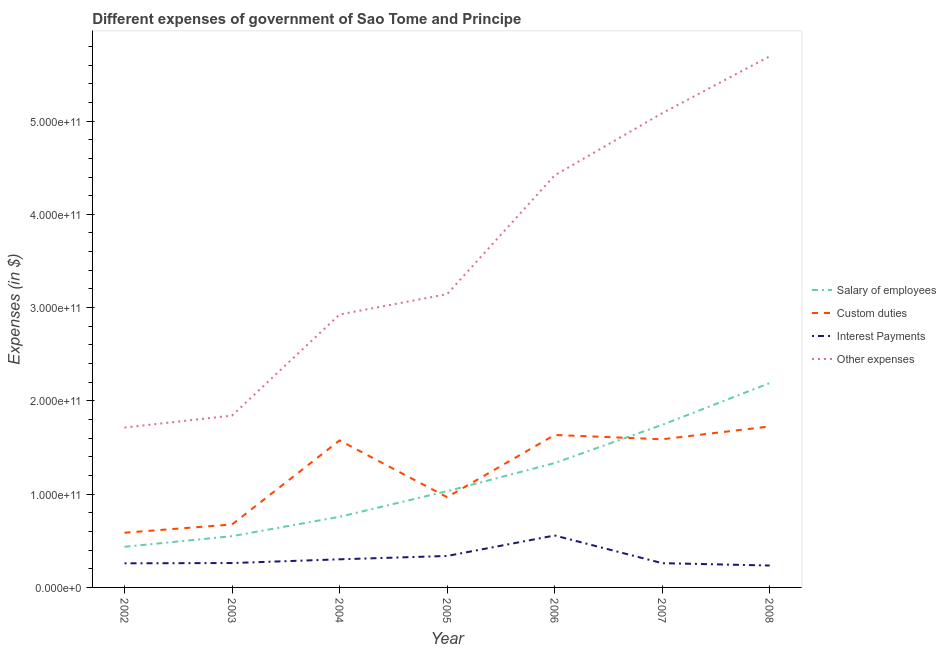How many different coloured lines are there?
Your answer should be very brief. 4. What is the amount spent on other expenses in 2008?
Offer a terse response. 5.69e+11. Across all years, what is the maximum amount spent on custom duties?
Give a very brief answer. 1.73e+11. Across all years, what is the minimum amount spent on other expenses?
Your answer should be very brief. 1.71e+11. In which year was the amount spent on interest payments minimum?
Offer a very short reply. 2008. What is the total amount spent on custom duties in the graph?
Your answer should be compact. 8.75e+11. What is the difference between the amount spent on interest payments in 2005 and that in 2006?
Your answer should be very brief. -2.20e+1. What is the difference between the amount spent on salary of employees in 2007 and the amount spent on other expenses in 2005?
Give a very brief answer. -1.40e+11. What is the average amount spent on interest payments per year?
Ensure brevity in your answer.  3.16e+1. In the year 2002, what is the difference between the amount spent on interest payments and amount spent on other expenses?
Offer a very short reply. -1.46e+11. What is the ratio of the amount spent on custom duties in 2003 to that in 2007?
Make the answer very short. 0.42. Is the difference between the amount spent on salary of employees in 2002 and 2008 greater than the difference between the amount spent on interest payments in 2002 and 2008?
Give a very brief answer. No. What is the difference between the highest and the second highest amount spent on salary of employees?
Your answer should be compact. 4.48e+1. What is the difference between the highest and the lowest amount spent on other expenses?
Offer a very short reply. 3.98e+11. Is it the case that in every year, the sum of the amount spent on interest payments and amount spent on custom duties is greater than the sum of amount spent on salary of employees and amount spent on other expenses?
Offer a terse response. Yes. Does the amount spent on custom duties monotonically increase over the years?
Your answer should be compact. No. Is the amount spent on salary of employees strictly greater than the amount spent on interest payments over the years?
Make the answer very short. Yes. What is the difference between two consecutive major ticks on the Y-axis?
Your response must be concise. 1.00e+11. How are the legend labels stacked?
Your answer should be very brief. Vertical. What is the title of the graph?
Provide a succinct answer. Different expenses of government of Sao Tome and Principe. Does "Secondary general education" appear as one of the legend labels in the graph?
Provide a succinct answer. No. What is the label or title of the X-axis?
Provide a short and direct response. Year. What is the label or title of the Y-axis?
Offer a terse response. Expenses (in $). What is the Expenses (in $) of Salary of employees in 2002?
Provide a succinct answer. 4.36e+1. What is the Expenses (in $) of Custom duties in 2002?
Your response must be concise. 5.87e+1. What is the Expenses (in $) in Interest Payments in 2002?
Offer a terse response. 2.59e+1. What is the Expenses (in $) of Other expenses in 2002?
Ensure brevity in your answer.  1.71e+11. What is the Expenses (in $) of Salary of employees in 2003?
Your answer should be very brief. 5.50e+1. What is the Expenses (in $) of Custom duties in 2003?
Keep it short and to the point. 6.75e+1. What is the Expenses (in $) of Interest Payments in 2003?
Ensure brevity in your answer.  2.61e+1. What is the Expenses (in $) of Other expenses in 2003?
Keep it short and to the point. 1.84e+11. What is the Expenses (in $) of Salary of employees in 2004?
Give a very brief answer. 7.57e+1. What is the Expenses (in $) of Custom duties in 2004?
Provide a short and direct response. 1.58e+11. What is the Expenses (in $) in Interest Payments in 2004?
Offer a terse response. 3.01e+1. What is the Expenses (in $) in Other expenses in 2004?
Offer a terse response. 2.93e+11. What is the Expenses (in $) in Salary of employees in 2005?
Ensure brevity in your answer.  1.03e+11. What is the Expenses (in $) in Custom duties in 2005?
Ensure brevity in your answer.  9.67e+1. What is the Expenses (in $) of Interest Payments in 2005?
Give a very brief answer. 3.37e+1. What is the Expenses (in $) in Other expenses in 2005?
Provide a short and direct response. 3.14e+11. What is the Expenses (in $) of Salary of employees in 2006?
Offer a very short reply. 1.33e+11. What is the Expenses (in $) of Custom duties in 2006?
Your answer should be compact. 1.63e+11. What is the Expenses (in $) in Interest Payments in 2006?
Offer a very short reply. 5.57e+1. What is the Expenses (in $) in Other expenses in 2006?
Keep it short and to the point. 4.42e+11. What is the Expenses (in $) in Salary of employees in 2007?
Offer a very short reply. 1.74e+11. What is the Expenses (in $) of Custom duties in 2007?
Your answer should be compact. 1.59e+11. What is the Expenses (in $) in Interest Payments in 2007?
Make the answer very short. 2.60e+1. What is the Expenses (in $) of Other expenses in 2007?
Your response must be concise. 5.08e+11. What is the Expenses (in $) of Salary of employees in 2008?
Ensure brevity in your answer.  2.19e+11. What is the Expenses (in $) of Custom duties in 2008?
Offer a very short reply. 1.73e+11. What is the Expenses (in $) in Interest Payments in 2008?
Make the answer very short. 2.35e+1. What is the Expenses (in $) of Other expenses in 2008?
Give a very brief answer. 5.69e+11. Across all years, what is the maximum Expenses (in $) in Salary of employees?
Keep it short and to the point. 2.19e+11. Across all years, what is the maximum Expenses (in $) of Custom duties?
Your response must be concise. 1.73e+11. Across all years, what is the maximum Expenses (in $) in Interest Payments?
Your response must be concise. 5.57e+1. Across all years, what is the maximum Expenses (in $) of Other expenses?
Offer a terse response. 5.69e+11. Across all years, what is the minimum Expenses (in $) of Salary of employees?
Your answer should be very brief. 4.36e+1. Across all years, what is the minimum Expenses (in $) of Custom duties?
Provide a succinct answer. 5.87e+1. Across all years, what is the minimum Expenses (in $) in Interest Payments?
Keep it short and to the point. 2.35e+1. Across all years, what is the minimum Expenses (in $) of Other expenses?
Ensure brevity in your answer.  1.71e+11. What is the total Expenses (in $) in Salary of employees in the graph?
Your response must be concise. 8.04e+11. What is the total Expenses (in $) in Custom duties in the graph?
Provide a short and direct response. 8.75e+11. What is the total Expenses (in $) in Interest Payments in the graph?
Give a very brief answer. 2.21e+11. What is the total Expenses (in $) in Other expenses in the graph?
Ensure brevity in your answer.  2.48e+12. What is the difference between the Expenses (in $) of Salary of employees in 2002 and that in 2003?
Your answer should be compact. -1.14e+1. What is the difference between the Expenses (in $) in Custom duties in 2002 and that in 2003?
Provide a short and direct response. -8.83e+09. What is the difference between the Expenses (in $) in Interest Payments in 2002 and that in 2003?
Offer a terse response. -2.93e+08. What is the difference between the Expenses (in $) in Other expenses in 2002 and that in 2003?
Make the answer very short. -1.29e+1. What is the difference between the Expenses (in $) in Salary of employees in 2002 and that in 2004?
Offer a very short reply. -3.22e+1. What is the difference between the Expenses (in $) of Custom duties in 2002 and that in 2004?
Ensure brevity in your answer.  -9.89e+1. What is the difference between the Expenses (in $) of Interest Payments in 2002 and that in 2004?
Ensure brevity in your answer.  -4.29e+09. What is the difference between the Expenses (in $) of Other expenses in 2002 and that in 2004?
Offer a terse response. -1.21e+11. What is the difference between the Expenses (in $) in Salary of employees in 2002 and that in 2005?
Offer a very short reply. -5.96e+1. What is the difference between the Expenses (in $) in Custom duties in 2002 and that in 2005?
Your answer should be compact. -3.81e+1. What is the difference between the Expenses (in $) of Interest Payments in 2002 and that in 2005?
Your response must be concise. -7.88e+09. What is the difference between the Expenses (in $) in Other expenses in 2002 and that in 2005?
Give a very brief answer. -1.43e+11. What is the difference between the Expenses (in $) of Salary of employees in 2002 and that in 2006?
Offer a terse response. -8.98e+1. What is the difference between the Expenses (in $) of Custom duties in 2002 and that in 2006?
Provide a short and direct response. -1.05e+11. What is the difference between the Expenses (in $) of Interest Payments in 2002 and that in 2006?
Your answer should be very brief. -2.98e+1. What is the difference between the Expenses (in $) in Other expenses in 2002 and that in 2006?
Offer a very short reply. -2.70e+11. What is the difference between the Expenses (in $) in Salary of employees in 2002 and that in 2007?
Your answer should be very brief. -1.31e+11. What is the difference between the Expenses (in $) of Custom duties in 2002 and that in 2007?
Offer a very short reply. -1.00e+11. What is the difference between the Expenses (in $) of Interest Payments in 2002 and that in 2007?
Your response must be concise. -1.67e+08. What is the difference between the Expenses (in $) of Other expenses in 2002 and that in 2007?
Your response must be concise. -3.37e+11. What is the difference between the Expenses (in $) in Salary of employees in 2002 and that in 2008?
Your response must be concise. -1.76e+11. What is the difference between the Expenses (in $) in Custom duties in 2002 and that in 2008?
Ensure brevity in your answer.  -1.14e+11. What is the difference between the Expenses (in $) of Interest Payments in 2002 and that in 2008?
Offer a terse response. 2.37e+09. What is the difference between the Expenses (in $) of Other expenses in 2002 and that in 2008?
Offer a terse response. -3.98e+11. What is the difference between the Expenses (in $) of Salary of employees in 2003 and that in 2004?
Ensure brevity in your answer.  -2.08e+1. What is the difference between the Expenses (in $) of Custom duties in 2003 and that in 2004?
Offer a very short reply. -9.01e+1. What is the difference between the Expenses (in $) of Interest Payments in 2003 and that in 2004?
Provide a succinct answer. -3.99e+09. What is the difference between the Expenses (in $) in Other expenses in 2003 and that in 2004?
Keep it short and to the point. -1.08e+11. What is the difference between the Expenses (in $) of Salary of employees in 2003 and that in 2005?
Offer a terse response. -4.82e+1. What is the difference between the Expenses (in $) of Custom duties in 2003 and that in 2005?
Provide a short and direct response. -2.93e+1. What is the difference between the Expenses (in $) in Interest Payments in 2003 and that in 2005?
Ensure brevity in your answer.  -7.58e+09. What is the difference between the Expenses (in $) of Other expenses in 2003 and that in 2005?
Offer a terse response. -1.30e+11. What is the difference between the Expenses (in $) in Salary of employees in 2003 and that in 2006?
Your answer should be very brief. -7.84e+1. What is the difference between the Expenses (in $) of Custom duties in 2003 and that in 2006?
Give a very brief answer. -9.60e+1. What is the difference between the Expenses (in $) in Interest Payments in 2003 and that in 2006?
Your answer should be very brief. -2.95e+1. What is the difference between the Expenses (in $) of Other expenses in 2003 and that in 2006?
Your answer should be very brief. -2.58e+11. What is the difference between the Expenses (in $) of Salary of employees in 2003 and that in 2007?
Keep it short and to the point. -1.19e+11. What is the difference between the Expenses (in $) in Custom duties in 2003 and that in 2007?
Your response must be concise. -9.13e+1. What is the difference between the Expenses (in $) of Interest Payments in 2003 and that in 2007?
Make the answer very short. 1.26e+08. What is the difference between the Expenses (in $) of Other expenses in 2003 and that in 2007?
Keep it short and to the point. -3.24e+11. What is the difference between the Expenses (in $) of Salary of employees in 2003 and that in 2008?
Offer a terse response. -1.64e+11. What is the difference between the Expenses (in $) of Custom duties in 2003 and that in 2008?
Your answer should be very brief. -1.05e+11. What is the difference between the Expenses (in $) of Interest Payments in 2003 and that in 2008?
Your response must be concise. 2.66e+09. What is the difference between the Expenses (in $) in Other expenses in 2003 and that in 2008?
Provide a succinct answer. -3.85e+11. What is the difference between the Expenses (in $) in Salary of employees in 2004 and that in 2005?
Provide a succinct answer. -2.75e+1. What is the difference between the Expenses (in $) in Custom duties in 2004 and that in 2005?
Make the answer very short. 6.09e+1. What is the difference between the Expenses (in $) in Interest Payments in 2004 and that in 2005?
Ensure brevity in your answer.  -3.59e+09. What is the difference between the Expenses (in $) of Other expenses in 2004 and that in 2005?
Ensure brevity in your answer.  -2.18e+1. What is the difference between the Expenses (in $) in Salary of employees in 2004 and that in 2006?
Provide a succinct answer. -5.76e+1. What is the difference between the Expenses (in $) of Custom duties in 2004 and that in 2006?
Keep it short and to the point. -5.86e+09. What is the difference between the Expenses (in $) in Interest Payments in 2004 and that in 2006?
Make the answer very short. -2.55e+1. What is the difference between the Expenses (in $) of Other expenses in 2004 and that in 2006?
Provide a succinct answer. -1.49e+11. What is the difference between the Expenses (in $) of Salary of employees in 2004 and that in 2007?
Your response must be concise. -9.86e+1. What is the difference between the Expenses (in $) in Custom duties in 2004 and that in 2007?
Keep it short and to the point. -1.22e+09. What is the difference between the Expenses (in $) of Interest Payments in 2004 and that in 2007?
Offer a very short reply. 4.12e+09. What is the difference between the Expenses (in $) in Other expenses in 2004 and that in 2007?
Provide a short and direct response. -2.16e+11. What is the difference between the Expenses (in $) of Salary of employees in 2004 and that in 2008?
Ensure brevity in your answer.  -1.43e+11. What is the difference between the Expenses (in $) of Custom duties in 2004 and that in 2008?
Your answer should be very brief. -1.50e+1. What is the difference between the Expenses (in $) of Interest Payments in 2004 and that in 2008?
Make the answer very short. 6.66e+09. What is the difference between the Expenses (in $) of Other expenses in 2004 and that in 2008?
Provide a succinct answer. -2.77e+11. What is the difference between the Expenses (in $) of Salary of employees in 2005 and that in 2006?
Your response must be concise. -3.01e+1. What is the difference between the Expenses (in $) of Custom duties in 2005 and that in 2006?
Give a very brief answer. -6.67e+1. What is the difference between the Expenses (in $) in Interest Payments in 2005 and that in 2006?
Keep it short and to the point. -2.20e+1. What is the difference between the Expenses (in $) in Other expenses in 2005 and that in 2006?
Keep it short and to the point. -1.27e+11. What is the difference between the Expenses (in $) of Salary of employees in 2005 and that in 2007?
Your answer should be very brief. -7.11e+1. What is the difference between the Expenses (in $) of Custom duties in 2005 and that in 2007?
Offer a very short reply. -6.21e+1. What is the difference between the Expenses (in $) of Interest Payments in 2005 and that in 2007?
Provide a short and direct response. 7.71e+09. What is the difference between the Expenses (in $) of Other expenses in 2005 and that in 2007?
Provide a short and direct response. -1.94e+11. What is the difference between the Expenses (in $) of Salary of employees in 2005 and that in 2008?
Your response must be concise. -1.16e+11. What is the difference between the Expenses (in $) in Custom duties in 2005 and that in 2008?
Your answer should be compact. -7.58e+1. What is the difference between the Expenses (in $) of Interest Payments in 2005 and that in 2008?
Offer a very short reply. 1.02e+1. What is the difference between the Expenses (in $) of Other expenses in 2005 and that in 2008?
Offer a terse response. -2.55e+11. What is the difference between the Expenses (in $) of Salary of employees in 2006 and that in 2007?
Your answer should be compact. -4.10e+1. What is the difference between the Expenses (in $) in Custom duties in 2006 and that in 2007?
Your response must be concise. 4.64e+09. What is the difference between the Expenses (in $) of Interest Payments in 2006 and that in 2007?
Make the answer very short. 2.97e+1. What is the difference between the Expenses (in $) in Other expenses in 2006 and that in 2007?
Your answer should be compact. -6.67e+1. What is the difference between the Expenses (in $) in Salary of employees in 2006 and that in 2008?
Make the answer very short. -8.58e+1. What is the difference between the Expenses (in $) of Custom duties in 2006 and that in 2008?
Offer a very short reply. -9.11e+09. What is the difference between the Expenses (in $) in Interest Payments in 2006 and that in 2008?
Provide a succinct answer. 3.22e+1. What is the difference between the Expenses (in $) in Other expenses in 2006 and that in 2008?
Provide a short and direct response. -1.28e+11. What is the difference between the Expenses (in $) in Salary of employees in 2007 and that in 2008?
Your response must be concise. -4.48e+1. What is the difference between the Expenses (in $) in Custom duties in 2007 and that in 2008?
Make the answer very short. -1.38e+1. What is the difference between the Expenses (in $) in Interest Payments in 2007 and that in 2008?
Provide a succinct answer. 2.54e+09. What is the difference between the Expenses (in $) in Other expenses in 2007 and that in 2008?
Ensure brevity in your answer.  -6.10e+1. What is the difference between the Expenses (in $) in Salary of employees in 2002 and the Expenses (in $) in Custom duties in 2003?
Offer a very short reply. -2.39e+1. What is the difference between the Expenses (in $) in Salary of employees in 2002 and the Expenses (in $) in Interest Payments in 2003?
Give a very brief answer. 1.74e+1. What is the difference between the Expenses (in $) of Salary of employees in 2002 and the Expenses (in $) of Other expenses in 2003?
Provide a short and direct response. -1.41e+11. What is the difference between the Expenses (in $) of Custom duties in 2002 and the Expenses (in $) of Interest Payments in 2003?
Your response must be concise. 3.25e+1. What is the difference between the Expenses (in $) of Custom duties in 2002 and the Expenses (in $) of Other expenses in 2003?
Provide a succinct answer. -1.26e+11. What is the difference between the Expenses (in $) of Interest Payments in 2002 and the Expenses (in $) of Other expenses in 2003?
Give a very brief answer. -1.58e+11. What is the difference between the Expenses (in $) in Salary of employees in 2002 and the Expenses (in $) in Custom duties in 2004?
Give a very brief answer. -1.14e+11. What is the difference between the Expenses (in $) of Salary of employees in 2002 and the Expenses (in $) of Interest Payments in 2004?
Provide a short and direct response. 1.34e+1. What is the difference between the Expenses (in $) in Salary of employees in 2002 and the Expenses (in $) in Other expenses in 2004?
Offer a terse response. -2.49e+11. What is the difference between the Expenses (in $) of Custom duties in 2002 and the Expenses (in $) of Interest Payments in 2004?
Provide a short and direct response. 2.85e+1. What is the difference between the Expenses (in $) in Custom duties in 2002 and the Expenses (in $) in Other expenses in 2004?
Your answer should be very brief. -2.34e+11. What is the difference between the Expenses (in $) in Interest Payments in 2002 and the Expenses (in $) in Other expenses in 2004?
Make the answer very short. -2.67e+11. What is the difference between the Expenses (in $) in Salary of employees in 2002 and the Expenses (in $) in Custom duties in 2005?
Offer a terse response. -5.32e+1. What is the difference between the Expenses (in $) in Salary of employees in 2002 and the Expenses (in $) in Interest Payments in 2005?
Your answer should be compact. 9.84e+09. What is the difference between the Expenses (in $) of Salary of employees in 2002 and the Expenses (in $) of Other expenses in 2005?
Offer a terse response. -2.71e+11. What is the difference between the Expenses (in $) in Custom duties in 2002 and the Expenses (in $) in Interest Payments in 2005?
Keep it short and to the point. 2.49e+1. What is the difference between the Expenses (in $) of Custom duties in 2002 and the Expenses (in $) of Other expenses in 2005?
Make the answer very short. -2.56e+11. What is the difference between the Expenses (in $) in Interest Payments in 2002 and the Expenses (in $) in Other expenses in 2005?
Offer a very short reply. -2.89e+11. What is the difference between the Expenses (in $) of Salary of employees in 2002 and the Expenses (in $) of Custom duties in 2006?
Offer a terse response. -1.20e+11. What is the difference between the Expenses (in $) in Salary of employees in 2002 and the Expenses (in $) in Interest Payments in 2006?
Your response must be concise. -1.21e+1. What is the difference between the Expenses (in $) of Salary of employees in 2002 and the Expenses (in $) of Other expenses in 2006?
Your response must be concise. -3.98e+11. What is the difference between the Expenses (in $) of Custom duties in 2002 and the Expenses (in $) of Interest Payments in 2006?
Your answer should be compact. 2.98e+09. What is the difference between the Expenses (in $) in Custom duties in 2002 and the Expenses (in $) in Other expenses in 2006?
Your response must be concise. -3.83e+11. What is the difference between the Expenses (in $) in Interest Payments in 2002 and the Expenses (in $) in Other expenses in 2006?
Your response must be concise. -4.16e+11. What is the difference between the Expenses (in $) in Salary of employees in 2002 and the Expenses (in $) in Custom duties in 2007?
Provide a succinct answer. -1.15e+11. What is the difference between the Expenses (in $) in Salary of employees in 2002 and the Expenses (in $) in Interest Payments in 2007?
Offer a terse response. 1.75e+1. What is the difference between the Expenses (in $) in Salary of employees in 2002 and the Expenses (in $) in Other expenses in 2007?
Make the answer very short. -4.65e+11. What is the difference between the Expenses (in $) in Custom duties in 2002 and the Expenses (in $) in Interest Payments in 2007?
Give a very brief answer. 3.26e+1. What is the difference between the Expenses (in $) in Custom duties in 2002 and the Expenses (in $) in Other expenses in 2007?
Your response must be concise. -4.50e+11. What is the difference between the Expenses (in $) in Interest Payments in 2002 and the Expenses (in $) in Other expenses in 2007?
Provide a short and direct response. -4.83e+11. What is the difference between the Expenses (in $) of Salary of employees in 2002 and the Expenses (in $) of Custom duties in 2008?
Provide a short and direct response. -1.29e+11. What is the difference between the Expenses (in $) in Salary of employees in 2002 and the Expenses (in $) in Interest Payments in 2008?
Your answer should be very brief. 2.01e+1. What is the difference between the Expenses (in $) in Salary of employees in 2002 and the Expenses (in $) in Other expenses in 2008?
Provide a short and direct response. -5.26e+11. What is the difference between the Expenses (in $) of Custom duties in 2002 and the Expenses (in $) of Interest Payments in 2008?
Offer a terse response. 3.52e+1. What is the difference between the Expenses (in $) of Custom duties in 2002 and the Expenses (in $) of Other expenses in 2008?
Provide a succinct answer. -5.11e+11. What is the difference between the Expenses (in $) in Interest Payments in 2002 and the Expenses (in $) in Other expenses in 2008?
Ensure brevity in your answer.  -5.44e+11. What is the difference between the Expenses (in $) in Salary of employees in 2003 and the Expenses (in $) in Custom duties in 2004?
Make the answer very short. -1.03e+11. What is the difference between the Expenses (in $) of Salary of employees in 2003 and the Expenses (in $) of Interest Payments in 2004?
Offer a terse response. 2.48e+1. What is the difference between the Expenses (in $) of Salary of employees in 2003 and the Expenses (in $) of Other expenses in 2004?
Give a very brief answer. -2.38e+11. What is the difference between the Expenses (in $) of Custom duties in 2003 and the Expenses (in $) of Interest Payments in 2004?
Provide a short and direct response. 3.74e+1. What is the difference between the Expenses (in $) in Custom duties in 2003 and the Expenses (in $) in Other expenses in 2004?
Ensure brevity in your answer.  -2.25e+11. What is the difference between the Expenses (in $) of Interest Payments in 2003 and the Expenses (in $) of Other expenses in 2004?
Ensure brevity in your answer.  -2.66e+11. What is the difference between the Expenses (in $) of Salary of employees in 2003 and the Expenses (in $) of Custom duties in 2005?
Offer a very short reply. -4.18e+1. What is the difference between the Expenses (in $) of Salary of employees in 2003 and the Expenses (in $) of Interest Payments in 2005?
Offer a very short reply. 2.12e+1. What is the difference between the Expenses (in $) in Salary of employees in 2003 and the Expenses (in $) in Other expenses in 2005?
Keep it short and to the point. -2.59e+11. What is the difference between the Expenses (in $) in Custom duties in 2003 and the Expenses (in $) in Interest Payments in 2005?
Provide a short and direct response. 3.38e+1. What is the difference between the Expenses (in $) of Custom duties in 2003 and the Expenses (in $) of Other expenses in 2005?
Give a very brief answer. -2.47e+11. What is the difference between the Expenses (in $) in Interest Payments in 2003 and the Expenses (in $) in Other expenses in 2005?
Ensure brevity in your answer.  -2.88e+11. What is the difference between the Expenses (in $) in Salary of employees in 2003 and the Expenses (in $) in Custom duties in 2006?
Ensure brevity in your answer.  -1.09e+11. What is the difference between the Expenses (in $) of Salary of employees in 2003 and the Expenses (in $) of Interest Payments in 2006?
Offer a terse response. -7.23e+08. What is the difference between the Expenses (in $) of Salary of employees in 2003 and the Expenses (in $) of Other expenses in 2006?
Your answer should be compact. -3.87e+11. What is the difference between the Expenses (in $) of Custom duties in 2003 and the Expenses (in $) of Interest Payments in 2006?
Offer a terse response. 1.18e+1. What is the difference between the Expenses (in $) of Custom duties in 2003 and the Expenses (in $) of Other expenses in 2006?
Your answer should be very brief. -3.74e+11. What is the difference between the Expenses (in $) of Interest Payments in 2003 and the Expenses (in $) of Other expenses in 2006?
Make the answer very short. -4.16e+11. What is the difference between the Expenses (in $) in Salary of employees in 2003 and the Expenses (in $) in Custom duties in 2007?
Your response must be concise. -1.04e+11. What is the difference between the Expenses (in $) in Salary of employees in 2003 and the Expenses (in $) in Interest Payments in 2007?
Your answer should be very brief. 2.89e+1. What is the difference between the Expenses (in $) in Salary of employees in 2003 and the Expenses (in $) in Other expenses in 2007?
Your answer should be very brief. -4.53e+11. What is the difference between the Expenses (in $) in Custom duties in 2003 and the Expenses (in $) in Interest Payments in 2007?
Your answer should be compact. 4.15e+1. What is the difference between the Expenses (in $) of Custom duties in 2003 and the Expenses (in $) of Other expenses in 2007?
Keep it short and to the point. -4.41e+11. What is the difference between the Expenses (in $) of Interest Payments in 2003 and the Expenses (in $) of Other expenses in 2007?
Your answer should be very brief. -4.82e+11. What is the difference between the Expenses (in $) of Salary of employees in 2003 and the Expenses (in $) of Custom duties in 2008?
Keep it short and to the point. -1.18e+11. What is the difference between the Expenses (in $) of Salary of employees in 2003 and the Expenses (in $) of Interest Payments in 2008?
Provide a succinct answer. 3.15e+1. What is the difference between the Expenses (in $) in Salary of employees in 2003 and the Expenses (in $) in Other expenses in 2008?
Provide a succinct answer. -5.14e+11. What is the difference between the Expenses (in $) in Custom duties in 2003 and the Expenses (in $) in Interest Payments in 2008?
Provide a short and direct response. 4.40e+1. What is the difference between the Expenses (in $) in Custom duties in 2003 and the Expenses (in $) in Other expenses in 2008?
Offer a very short reply. -5.02e+11. What is the difference between the Expenses (in $) in Interest Payments in 2003 and the Expenses (in $) in Other expenses in 2008?
Provide a succinct answer. -5.43e+11. What is the difference between the Expenses (in $) of Salary of employees in 2004 and the Expenses (in $) of Custom duties in 2005?
Make the answer very short. -2.10e+1. What is the difference between the Expenses (in $) in Salary of employees in 2004 and the Expenses (in $) in Interest Payments in 2005?
Make the answer very short. 4.20e+1. What is the difference between the Expenses (in $) of Salary of employees in 2004 and the Expenses (in $) of Other expenses in 2005?
Give a very brief answer. -2.39e+11. What is the difference between the Expenses (in $) in Custom duties in 2004 and the Expenses (in $) in Interest Payments in 2005?
Give a very brief answer. 1.24e+11. What is the difference between the Expenses (in $) in Custom duties in 2004 and the Expenses (in $) in Other expenses in 2005?
Offer a very short reply. -1.57e+11. What is the difference between the Expenses (in $) in Interest Payments in 2004 and the Expenses (in $) in Other expenses in 2005?
Ensure brevity in your answer.  -2.84e+11. What is the difference between the Expenses (in $) in Salary of employees in 2004 and the Expenses (in $) in Custom duties in 2006?
Keep it short and to the point. -8.77e+1. What is the difference between the Expenses (in $) of Salary of employees in 2004 and the Expenses (in $) of Interest Payments in 2006?
Provide a succinct answer. 2.01e+1. What is the difference between the Expenses (in $) of Salary of employees in 2004 and the Expenses (in $) of Other expenses in 2006?
Provide a short and direct response. -3.66e+11. What is the difference between the Expenses (in $) in Custom duties in 2004 and the Expenses (in $) in Interest Payments in 2006?
Your response must be concise. 1.02e+11. What is the difference between the Expenses (in $) in Custom duties in 2004 and the Expenses (in $) in Other expenses in 2006?
Offer a terse response. -2.84e+11. What is the difference between the Expenses (in $) in Interest Payments in 2004 and the Expenses (in $) in Other expenses in 2006?
Offer a very short reply. -4.12e+11. What is the difference between the Expenses (in $) of Salary of employees in 2004 and the Expenses (in $) of Custom duties in 2007?
Your answer should be very brief. -8.31e+1. What is the difference between the Expenses (in $) of Salary of employees in 2004 and the Expenses (in $) of Interest Payments in 2007?
Make the answer very short. 4.97e+1. What is the difference between the Expenses (in $) of Salary of employees in 2004 and the Expenses (in $) of Other expenses in 2007?
Keep it short and to the point. -4.33e+11. What is the difference between the Expenses (in $) in Custom duties in 2004 and the Expenses (in $) in Interest Payments in 2007?
Keep it short and to the point. 1.32e+11. What is the difference between the Expenses (in $) of Custom duties in 2004 and the Expenses (in $) of Other expenses in 2007?
Ensure brevity in your answer.  -3.51e+11. What is the difference between the Expenses (in $) of Interest Payments in 2004 and the Expenses (in $) of Other expenses in 2007?
Offer a terse response. -4.78e+11. What is the difference between the Expenses (in $) in Salary of employees in 2004 and the Expenses (in $) in Custom duties in 2008?
Offer a terse response. -9.68e+1. What is the difference between the Expenses (in $) of Salary of employees in 2004 and the Expenses (in $) of Interest Payments in 2008?
Offer a terse response. 5.23e+1. What is the difference between the Expenses (in $) in Salary of employees in 2004 and the Expenses (in $) in Other expenses in 2008?
Keep it short and to the point. -4.94e+11. What is the difference between the Expenses (in $) in Custom duties in 2004 and the Expenses (in $) in Interest Payments in 2008?
Ensure brevity in your answer.  1.34e+11. What is the difference between the Expenses (in $) of Custom duties in 2004 and the Expenses (in $) of Other expenses in 2008?
Make the answer very short. -4.12e+11. What is the difference between the Expenses (in $) of Interest Payments in 2004 and the Expenses (in $) of Other expenses in 2008?
Provide a short and direct response. -5.39e+11. What is the difference between the Expenses (in $) in Salary of employees in 2005 and the Expenses (in $) in Custom duties in 2006?
Provide a short and direct response. -6.03e+1. What is the difference between the Expenses (in $) of Salary of employees in 2005 and the Expenses (in $) of Interest Payments in 2006?
Provide a short and direct response. 4.75e+1. What is the difference between the Expenses (in $) of Salary of employees in 2005 and the Expenses (in $) of Other expenses in 2006?
Ensure brevity in your answer.  -3.39e+11. What is the difference between the Expenses (in $) in Custom duties in 2005 and the Expenses (in $) in Interest Payments in 2006?
Keep it short and to the point. 4.11e+1. What is the difference between the Expenses (in $) of Custom duties in 2005 and the Expenses (in $) of Other expenses in 2006?
Offer a terse response. -3.45e+11. What is the difference between the Expenses (in $) in Interest Payments in 2005 and the Expenses (in $) in Other expenses in 2006?
Provide a short and direct response. -4.08e+11. What is the difference between the Expenses (in $) of Salary of employees in 2005 and the Expenses (in $) of Custom duties in 2007?
Provide a succinct answer. -5.56e+1. What is the difference between the Expenses (in $) of Salary of employees in 2005 and the Expenses (in $) of Interest Payments in 2007?
Offer a terse response. 7.72e+1. What is the difference between the Expenses (in $) in Salary of employees in 2005 and the Expenses (in $) in Other expenses in 2007?
Your response must be concise. -4.05e+11. What is the difference between the Expenses (in $) in Custom duties in 2005 and the Expenses (in $) in Interest Payments in 2007?
Your response must be concise. 7.07e+1. What is the difference between the Expenses (in $) in Custom duties in 2005 and the Expenses (in $) in Other expenses in 2007?
Give a very brief answer. -4.12e+11. What is the difference between the Expenses (in $) in Interest Payments in 2005 and the Expenses (in $) in Other expenses in 2007?
Your response must be concise. -4.75e+11. What is the difference between the Expenses (in $) of Salary of employees in 2005 and the Expenses (in $) of Custom duties in 2008?
Provide a short and direct response. -6.94e+1. What is the difference between the Expenses (in $) in Salary of employees in 2005 and the Expenses (in $) in Interest Payments in 2008?
Keep it short and to the point. 7.97e+1. What is the difference between the Expenses (in $) of Salary of employees in 2005 and the Expenses (in $) of Other expenses in 2008?
Your response must be concise. -4.66e+11. What is the difference between the Expenses (in $) of Custom duties in 2005 and the Expenses (in $) of Interest Payments in 2008?
Provide a succinct answer. 7.33e+1. What is the difference between the Expenses (in $) in Custom duties in 2005 and the Expenses (in $) in Other expenses in 2008?
Ensure brevity in your answer.  -4.73e+11. What is the difference between the Expenses (in $) in Interest Payments in 2005 and the Expenses (in $) in Other expenses in 2008?
Offer a terse response. -5.36e+11. What is the difference between the Expenses (in $) in Salary of employees in 2006 and the Expenses (in $) in Custom duties in 2007?
Ensure brevity in your answer.  -2.55e+1. What is the difference between the Expenses (in $) in Salary of employees in 2006 and the Expenses (in $) in Interest Payments in 2007?
Provide a short and direct response. 1.07e+11. What is the difference between the Expenses (in $) of Salary of employees in 2006 and the Expenses (in $) of Other expenses in 2007?
Provide a succinct answer. -3.75e+11. What is the difference between the Expenses (in $) in Custom duties in 2006 and the Expenses (in $) in Interest Payments in 2007?
Give a very brief answer. 1.37e+11. What is the difference between the Expenses (in $) in Custom duties in 2006 and the Expenses (in $) in Other expenses in 2007?
Your response must be concise. -3.45e+11. What is the difference between the Expenses (in $) in Interest Payments in 2006 and the Expenses (in $) in Other expenses in 2007?
Make the answer very short. -4.53e+11. What is the difference between the Expenses (in $) of Salary of employees in 2006 and the Expenses (in $) of Custom duties in 2008?
Offer a terse response. -3.93e+1. What is the difference between the Expenses (in $) in Salary of employees in 2006 and the Expenses (in $) in Interest Payments in 2008?
Provide a succinct answer. 1.10e+11. What is the difference between the Expenses (in $) of Salary of employees in 2006 and the Expenses (in $) of Other expenses in 2008?
Keep it short and to the point. -4.36e+11. What is the difference between the Expenses (in $) in Custom duties in 2006 and the Expenses (in $) in Interest Payments in 2008?
Ensure brevity in your answer.  1.40e+11. What is the difference between the Expenses (in $) in Custom duties in 2006 and the Expenses (in $) in Other expenses in 2008?
Offer a terse response. -4.06e+11. What is the difference between the Expenses (in $) in Interest Payments in 2006 and the Expenses (in $) in Other expenses in 2008?
Keep it short and to the point. -5.14e+11. What is the difference between the Expenses (in $) in Salary of employees in 2007 and the Expenses (in $) in Custom duties in 2008?
Give a very brief answer. 1.75e+09. What is the difference between the Expenses (in $) of Salary of employees in 2007 and the Expenses (in $) of Interest Payments in 2008?
Provide a succinct answer. 1.51e+11. What is the difference between the Expenses (in $) in Salary of employees in 2007 and the Expenses (in $) in Other expenses in 2008?
Keep it short and to the point. -3.95e+11. What is the difference between the Expenses (in $) of Custom duties in 2007 and the Expenses (in $) of Interest Payments in 2008?
Give a very brief answer. 1.35e+11. What is the difference between the Expenses (in $) of Custom duties in 2007 and the Expenses (in $) of Other expenses in 2008?
Ensure brevity in your answer.  -4.11e+11. What is the difference between the Expenses (in $) in Interest Payments in 2007 and the Expenses (in $) in Other expenses in 2008?
Make the answer very short. -5.43e+11. What is the average Expenses (in $) in Salary of employees per year?
Ensure brevity in your answer.  1.15e+11. What is the average Expenses (in $) in Custom duties per year?
Give a very brief answer. 1.25e+11. What is the average Expenses (in $) of Interest Payments per year?
Ensure brevity in your answer.  3.16e+1. What is the average Expenses (in $) in Other expenses per year?
Provide a succinct answer. 3.55e+11. In the year 2002, what is the difference between the Expenses (in $) of Salary of employees and Expenses (in $) of Custom duties?
Offer a very short reply. -1.51e+1. In the year 2002, what is the difference between the Expenses (in $) of Salary of employees and Expenses (in $) of Interest Payments?
Ensure brevity in your answer.  1.77e+1. In the year 2002, what is the difference between the Expenses (in $) of Salary of employees and Expenses (in $) of Other expenses?
Offer a very short reply. -1.28e+11. In the year 2002, what is the difference between the Expenses (in $) of Custom duties and Expenses (in $) of Interest Payments?
Your answer should be compact. 3.28e+1. In the year 2002, what is the difference between the Expenses (in $) of Custom duties and Expenses (in $) of Other expenses?
Your answer should be very brief. -1.13e+11. In the year 2002, what is the difference between the Expenses (in $) of Interest Payments and Expenses (in $) of Other expenses?
Give a very brief answer. -1.46e+11. In the year 2003, what is the difference between the Expenses (in $) of Salary of employees and Expenses (in $) of Custom duties?
Your answer should be very brief. -1.25e+1. In the year 2003, what is the difference between the Expenses (in $) of Salary of employees and Expenses (in $) of Interest Payments?
Provide a short and direct response. 2.88e+1. In the year 2003, what is the difference between the Expenses (in $) of Salary of employees and Expenses (in $) of Other expenses?
Provide a succinct answer. -1.29e+11. In the year 2003, what is the difference between the Expenses (in $) in Custom duties and Expenses (in $) in Interest Payments?
Your answer should be compact. 4.14e+1. In the year 2003, what is the difference between the Expenses (in $) of Custom duties and Expenses (in $) of Other expenses?
Keep it short and to the point. -1.17e+11. In the year 2003, what is the difference between the Expenses (in $) of Interest Payments and Expenses (in $) of Other expenses?
Give a very brief answer. -1.58e+11. In the year 2004, what is the difference between the Expenses (in $) of Salary of employees and Expenses (in $) of Custom duties?
Your answer should be compact. -8.19e+1. In the year 2004, what is the difference between the Expenses (in $) of Salary of employees and Expenses (in $) of Interest Payments?
Provide a short and direct response. 4.56e+1. In the year 2004, what is the difference between the Expenses (in $) of Salary of employees and Expenses (in $) of Other expenses?
Offer a terse response. -2.17e+11. In the year 2004, what is the difference between the Expenses (in $) in Custom duties and Expenses (in $) in Interest Payments?
Offer a terse response. 1.27e+11. In the year 2004, what is the difference between the Expenses (in $) in Custom duties and Expenses (in $) in Other expenses?
Keep it short and to the point. -1.35e+11. In the year 2004, what is the difference between the Expenses (in $) in Interest Payments and Expenses (in $) in Other expenses?
Give a very brief answer. -2.62e+11. In the year 2005, what is the difference between the Expenses (in $) in Salary of employees and Expenses (in $) in Custom duties?
Offer a terse response. 6.45e+09. In the year 2005, what is the difference between the Expenses (in $) of Salary of employees and Expenses (in $) of Interest Payments?
Your answer should be very brief. 6.95e+1. In the year 2005, what is the difference between the Expenses (in $) of Salary of employees and Expenses (in $) of Other expenses?
Your response must be concise. -2.11e+11. In the year 2005, what is the difference between the Expenses (in $) of Custom duties and Expenses (in $) of Interest Payments?
Make the answer very short. 6.30e+1. In the year 2005, what is the difference between the Expenses (in $) of Custom duties and Expenses (in $) of Other expenses?
Offer a terse response. -2.18e+11. In the year 2005, what is the difference between the Expenses (in $) in Interest Payments and Expenses (in $) in Other expenses?
Your answer should be very brief. -2.81e+11. In the year 2006, what is the difference between the Expenses (in $) in Salary of employees and Expenses (in $) in Custom duties?
Provide a short and direct response. -3.01e+1. In the year 2006, what is the difference between the Expenses (in $) in Salary of employees and Expenses (in $) in Interest Payments?
Offer a very short reply. 7.76e+1. In the year 2006, what is the difference between the Expenses (in $) of Salary of employees and Expenses (in $) of Other expenses?
Your response must be concise. -3.08e+11. In the year 2006, what is the difference between the Expenses (in $) in Custom duties and Expenses (in $) in Interest Payments?
Provide a succinct answer. 1.08e+11. In the year 2006, what is the difference between the Expenses (in $) in Custom duties and Expenses (in $) in Other expenses?
Offer a very short reply. -2.78e+11. In the year 2006, what is the difference between the Expenses (in $) of Interest Payments and Expenses (in $) of Other expenses?
Offer a very short reply. -3.86e+11. In the year 2007, what is the difference between the Expenses (in $) in Salary of employees and Expenses (in $) in Custom duties?
Ensure brevity in your answer.  1.55e+1. In the year 2007, what is the difference between the Expenses (in $) of Salary of employees and Expenses (in $) of Interest Payments?
Give a very brief answer. 1.48e+11. In the year 2007, what is the difference between the Expenses (in $) of Salary of employees and Expenses (in $) of Other expenses?
Provide a succinct answer. -3.34e+11. In the year 2007, what is the difference between the Expenses (in $) of Custom duties and Expenses (in $) of Interest Payments?
Ensure brevity in your answer.  1.33e+11. In the year 2007, what is the difference between the Expenses (in $) of Custom duties and Expenses (in $) of Other expenses?
Ensure brevity in your answer.  -3.50e+11. In the year 2007, what is the difference between the Expenses (in $) of Interest Payments and Expenses (in $) of Other expenses?
Your answer should be compact. -4.82e+11. In the year 2008, what is the difference between the Expenses (in $) in Salary of employees and Expenses (in $) in Custom duties?
Keep it short and to the point. 4.65e+1. In the year 2008, what is the difference between the Expenses (in $) in Salary of employees and Expenses (in $) in Interest Payments?
Your response must be concise. 1.96e+11. In the year 2008, what is the difference between the Expenses (in $) in Salary of employees and Expenses (in $) in Other expenses?
Offer a terse response. -3.50e+11. In the year 2008, what is the difference between the Expenses (in $) in Custom duties and Expenses (in $) in Interest Payments?
Offer a terse response. 1.49e+11. In the year 2008, what is the difference between the Expenses (in $) in Custom duties and Expenses (in $) in Other expenses?
Offer a very short reply. -3.97e+11. In the year 2008, what is the difference between the Expenses (in $) of Interest Payments and Expenses (in $) of Other expenses?
Your response must be concise. -5.46e+11. What is the ratio of the Expenses (in $) of Salary of employees in 2002 to that in 2003?
Ensure brevity in your answer.  0.79. What is the ratio of the Expenses (in $) in Custom duties in 2002 to that in 2003?
Ensure brevity in your answer.  0.87. What is the ratio of the Expenses (in $) of Other expenses in 2002 to that in 2003?
Give a very brief answer. 0.93. What is the ratio of the Expenses (in $) of Salary of employees in 2002 to that in 2004?
Ensure brevity in your answer.  0.58. What is the ratio of the Expenses (in $) of Custom duties in 2002 to that in 2004?
Offer a terse response. 0.37. What is the ratio of the Expenses (in $) in Interest Payments in 2002 to that in 2004?
Your answer should be compact. 0.86. What is the ratio of the Expenses (in $) in Other expenses in 2002 to that in 2004?
Give a very brief answer. 0.59. What is the ratio of the Expenses (in $) of Salary of employees in 2002 to that in 2005?
Make the answer very short. 0.42. What is the ratio of the Expenses (in $) of Custom duties in 2002 to that in 2005?
Ensure brevity in your answer.  0.61. What is the ratio of the Expenses (in $) in Interest Payments in 2002 to that in 2005?
Give a very brief answer. 0.77. What is the ratio of the Expenses (in $) of Other expenses in 2002 to that in 2005?
Offer a very short reply. 0.55. What is the ratio of the Expenses (in $) of Salary of employees in 2002 to that in 2006?
Offer a very short reply. 0.33. What is the ratio of the Expenses (in $) of Custom duties in 2002 to that in 2006?
Your answer should be very brief. 0.36. What is the ratio of the Expenses (in $) of Interest Payments in 2002 to that in 2006?
Provide a succinct answer. 0.46. What is the ratio of the Expenses (in $) in Other expenses in 2002 to that in 2006?
Keep it short and to the point. 0.39. What is the ratio of the Expenses (in $) of Salary of employees in 2002 to that in 2007?
Your answer should be compact. 0.25. What is the ratio of the Expenses (in $) of Custom duties in 2002 to that in 2007?
Ensure brevity in your answer.  0.37. What is the ratio of the Expenses (in $) in Interest Payments in 2002 to that in 2007?
Your answer should be compact. 0.99. What is the ratio of the Expenses (in $) of Other expenses in 2002 to that in 2007?
Provide a succinct answer. 0.34. What is the ratio of the Expenses (in $) in Salary of employees in 2002 to that in 2008?
Your response must be concise. 0.2. What is the ratio of the Expenses (in $) in Custom duties in 2002 to that in 2008?
Your answer should be very brief. 0.34. What is the ratio of the Expenses (in $) of Interest Payments in 2002 to that in 2008?
Ensure brevity in your answer.  1.1. What is the ratio of the Expenses (in $) of Other expenses in 2002 to that in 2008?
Offer a terse response. 0.3. What is the ratio of the Expenses (in $) of Salary of employees in 2003 to that in 2004?
Your answer should be compact. 0.73. What is the ratio of the Expenses (in $) in Custom duties in 2003 to that in 2004?
Ensure brevity in your answer.  0.43. What is the ratio of the Expenses (in $) in Interest Payments in 2003 to that in 2004?
Provide a short and direct response. 0.87. What is the ratio of the Expenses (in $) of Other expenses in 2003 to that in 2004?
Ensure brevity in your answer.  0.63. What is the ratio of the Expenses (in $) in Salary of employees in 2003 to that in 2005?
Your response must be concise. 0.53. What is the ratio of the Expenses (in $) of Custom duties in 2003 to that in 2005?
Keep it short and to the point. 0.7. What is the ratio of the Expenses (in $) in Interest Payments in 2003 to that in 2005?
Provide a short and direct response. 0.78. What is the ratio of the Expenses (in $) of Other expenses in 2003 to that in 2005?
Give a very brief answer. 0.59. What is the ratio of the Expenses (in $) in Salary of employees in 2003 to that in 2006?
Your answer should be compact. 0.41. What is the ratio of the Expenses (in $) of Custom duties in 2003 to that in 2006?
Offer a terse response. 0.41. What is the ratio of the Expenses (in $) of Interest Payments in 2003 to that in 2006?
Your answer should be very brief. 0.47. What is the ratio of the Expenses (in $) in Other expenses in 2003 to that in 2006?
Your answer should be very brief. 0.42. What is the ratio of the Expenses (in $) in Salary of employees in 2003 to that in 2007?
Provide a succinct answer. 0.32. What is the ratio of the Expenses (in $) in Custom duties in 2003 to that in 2007?
Keep it short and to the point. 0.42. What is the ratio of the Expenses (in $) of Other expenses in 2003 to that in 2007?
Give a very brief answer. 0.36. What is the ratio of the Expenses (in $) in Salary of employees in 2003 to that in 2008?
Keep it short and to the point. 0.25. What is the ratio of the Expenses (in $) of Custom duties in 2003 to that in 2008?
Your response must be concise. 0.39. What is the ratio of the Expenses (in $) of Interest Payments in 2003 to that in 2008?
Offer a terse response. 1.11. What is the ratio of the Expenses (in $) of Other expenses in 2003 to that in 2008?
Your answer should be very brief. 0.32. What is the ratio of the Expenses (in $) in Salary of employees in 2004 to that in 2005?
Give a very brief answer. 0.73. What is the ratio of the Expenses (in $) in Custom duties in 2004 to that in 2005?
Keep it short and to the point. 1.63. What is the ratio of the Expenses (in $) in Interest Payments in 2004 to that in 2005?
Keep it short and to the point. 0.89. What is the ratio of the Expenses (in $) in Other expenses in 2004 to that in 2005?
Give a very brief answer. 0.93. What is the ratio of the Expenses (in $) of Salary of employees in 2004 to that in 2006?
Your answer should be compact. 0.57. What is the ratio of the Expenses (in $) in Custom duties in 2004 to that in 2006?
Ensure brevity in your answer.  0.96. What is the ratio of the Expenses (in $) in Interest Payments in 2004 to that in 2006?
Give a very brief answer. 0.54. What is the ratio of the Expenses (in $) in Other expenses in 2004 to that in 2006?
Your answer should be very brief. 0.66. What is the ratio of the Expenses (in $) in Salary of employees in 2004 to that in 2007?
Your response must be concise. 0.43. What is the ratio of the Expenses (in $) in Interest Payments in 2004 to that in 2007?
Keep it short and to the point. 1.16. What is the ratio of the Expenses (in $) of Other expenses in 2004 to that in 2007?
Make the answer very short. 0.58. What is the ratio of the Expenses (in $) of Salary of employees in 2004 to that in 2008?
Your answer should be very brief. 0.35. What is the ratio of the Expenses (in $) of Custom duties in 2004 to that in 2008?
Provide a succinct answer. 0.91. What is the ratio of the Expenses (in $) of Interest Payments in 2004 to that in 2008?
Offer a very short reply. 1.28. What is the ratio of the Expenses (in $) in Other expenses in 2004 to that in 2008?
Your response must be concise. 0.51. What is the ratio of the Expenses (in $) of Salary of employees in 2005 to that in 2006?
Your response must be concise. 0.77. What is the ratio of the Expenses (in $) of Custom duties in 2005 to that in 2006?
Your response must be concise. 0.59. What is the ratio of the Expenses (in $) in Interest Payments in 2005 to that in 2006?
Make the answer very short. 0.61. What is the ratio of the Expenses (in $) in Other expenses in 2005 to that in 2006?
Provide a succinct answer. 0.71. What is the ratio of the Expenses (in $) in Salary of employees in 2005 to that in 2007?
Keep it short and to the point. 0.59. What is the ratio of the Expenses (in $) in Custom duties in 2005 to that in 2007?
Your answer should be compact. 0.61. What is the ratio of the Expenses (in $) of Interest Payments in 2005 to that in 2007?
Ensure brevity in your answer.  1.3. What is the ratio of the Expenses (in $) in Other expenses in 2005 to that in 2007?
Provide a succinct answer. 0.62. What is the ratio of the Expenses (in $) in Salary of employees in 2005 to that in 2008?
Provide a short and direct response. 0.47. What is the ratio of the Expenses (in $) of Custom duties in 2005 to that in 2008?
Provide a short and direct response. 0.56. What is the ratio of the Expenses (in $) in Interest Payments in 2005 to that in 2008?
Provide a succinct answer. 1.44. What is the ratio of the Expenses (in $) of Other expenses in 2005 to that in 2008?
Ensure brevity in your answer.  0.55. What is the ratio of the Expenses (in $) in Salary of employees in 2006 to that in 2007?
Make the answer very short. 0.76. What is the ratio of the Expenses (in $) in Custom duties in 2006 to that in 2007?
Your answer should be very brief. 1.03. What is the ratio of the Expenses (in $) of Interest Payments in 2006 to that in 2007?
Ensure brevity in your answer.  2.14. What is the ratio of the Expenses (in $) of Other expenses in 2006 to that in 2007?
Provide a succinct answer. 0.87. What is the ratio of the Expenses (in $) of Salary of employees in 2006 to that in 2008?
Provide a succinct answer. 0.61. What is the ratio of the Expenses (in $) of Custom duties in 2006 to that in 2008?
Your answer should be very brief. 0.95. What is the ratio of the Expenses (in $) of Interest Payments in 2006 to that in 2008?
Offer a very short reply. 2.37. What is the ratio of the Expenses (in $) in Other expenses in 2006 to that in 2008?
Keep it short and to the point. 0.78. What is the ratio of the Expenses (in $) in Salary of employees in 2007 to that in 2008?
Your answer should be very brief. 0.8. What is the ratio of the Expenses (in $) in Custom duties in 2007 to that in 2008?
Provide a short and direct response. 0.92. What is the ratio of the Expenses (in $) in Interest Payments in 2007 to that in 2008?
Your answer should be compact. 1.11. What is the ratio of the Expenses (in $) in Other expenses in 2007 to that in 2008?
Offer a terse response. 0.89. What is the difference between the highest and the second highest Expenses (in $) in Salary of employees?
Provide a succinct answer. 4.48e+1. What is the difference between the highest and the second highest Expenses (in $) in Custom duties?
Keep it short and to the point. 9.11e+09. What is the difference between the highest and the second highest Expenses (in $) of Interest Payments?
Give a very brief answer. 2.20e+1. What is the difference between the highest and the second highest Expenses (in $) in Other expenses?
Provide a short and direct response. 6.10e+1. What is the difference between the highest and the lowest Expenses (in $) of Salary of employees?
Keep it short and to the point. 1.76e+11. What is the difference between the highest and the lowest Expenses (in $) of Custom duties?
Your answer should be compact. 1.14e+11. What is the difference between the highest and the lowest Expenses (in $) of Interest Payments?
Your answer should be compact. 3.22e+1. What is the difference between the highest and the lowest Expenses (in $) of Other expenses?
Keep it short and to the point. 3.98e+11. 